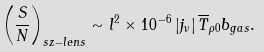<formula> <loc_0><loc_0><loc_500><loc_500>\left ( \frac { S } { N } \right ) _ { s z - l e n s } \sim l ^ { 2 } \times 1 0 ^ { - 6 } \left | j _ { \nu } \right | \overline { T } _ { \rho 0 } b _ { g a s } .</formula> 